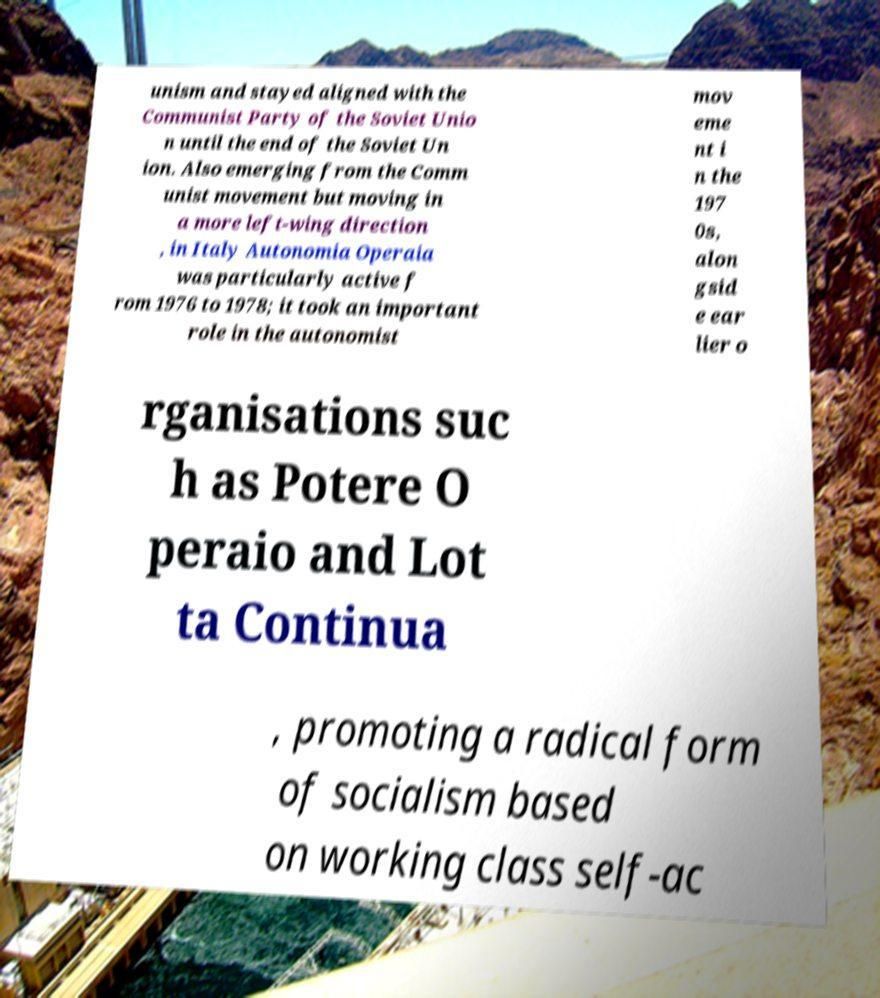Please identify and transcribe the text found in this image. unism and stayed aligned with the Communist Party of the Soviet Unio n until the end of the Soviet Un ion. Also emerging from the Comm unist movement but moving in a more left-wing direction , in Italy Autonomia Operaia was particularly active f rom 1976 to 1978; it took an important role in the autonomist mov eme nt i n the 197 0s, alon gsid e ear lier o rganisations suc h as Potere O peraio and Lot ta Continua , promoting a radical form of socialism based on working class self-ac 